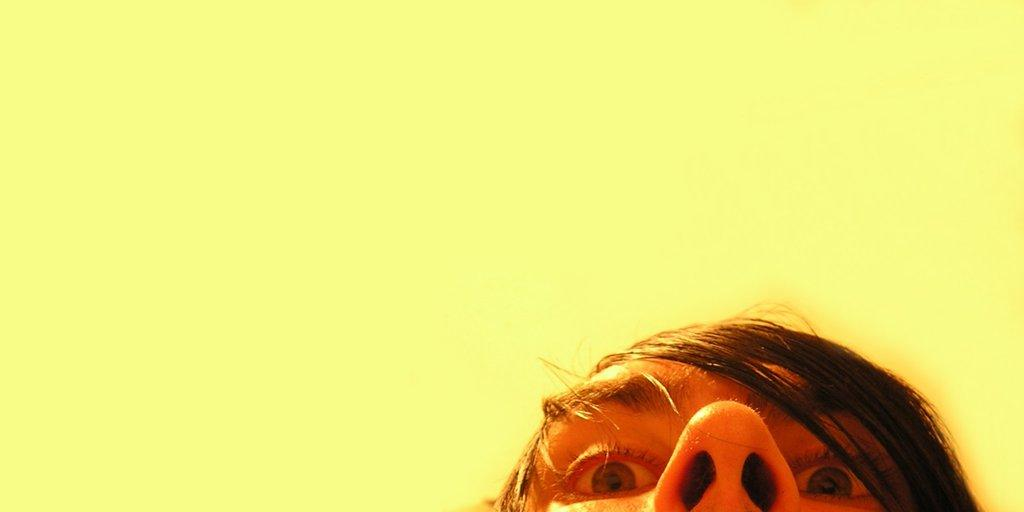What part of a person is shown in the image? There is a person's head in the image. What specific facial features are visible in the image? The person's eyes and nostrils are visible in the image. What can be seen on top of the person's head? The person's hair is visible in the image. What color is the surface behind the person's head? There is a yellow color surface behind the person's head. How many tomatoes can be seen on the person's head in the image? There are no tomatoes present on the person's head in the image. What type of fish is swimming near the person's hair in the image? There is no fish present near the person's hair in the image. 